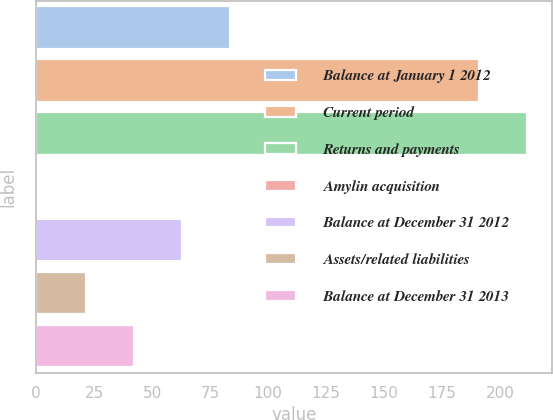Convert chart to OTSL. <chart><loc_0><loc_0><loc_500><loc_500><bar_chart><fcel>Balance at January 1 2012<fcel>Current period<fcel>Returns and payments<fcel>Amylin acquisition<fcel>Balance at December 31 2012<fcel>Assets/related liabilities<fcel>Balance at December 31 2013<nl><fcel>83.8<fcel>191<fcel>211.7<fcel>1<fcel>63.1<fcel>21.7<fcel>42.4<nl></chart> 